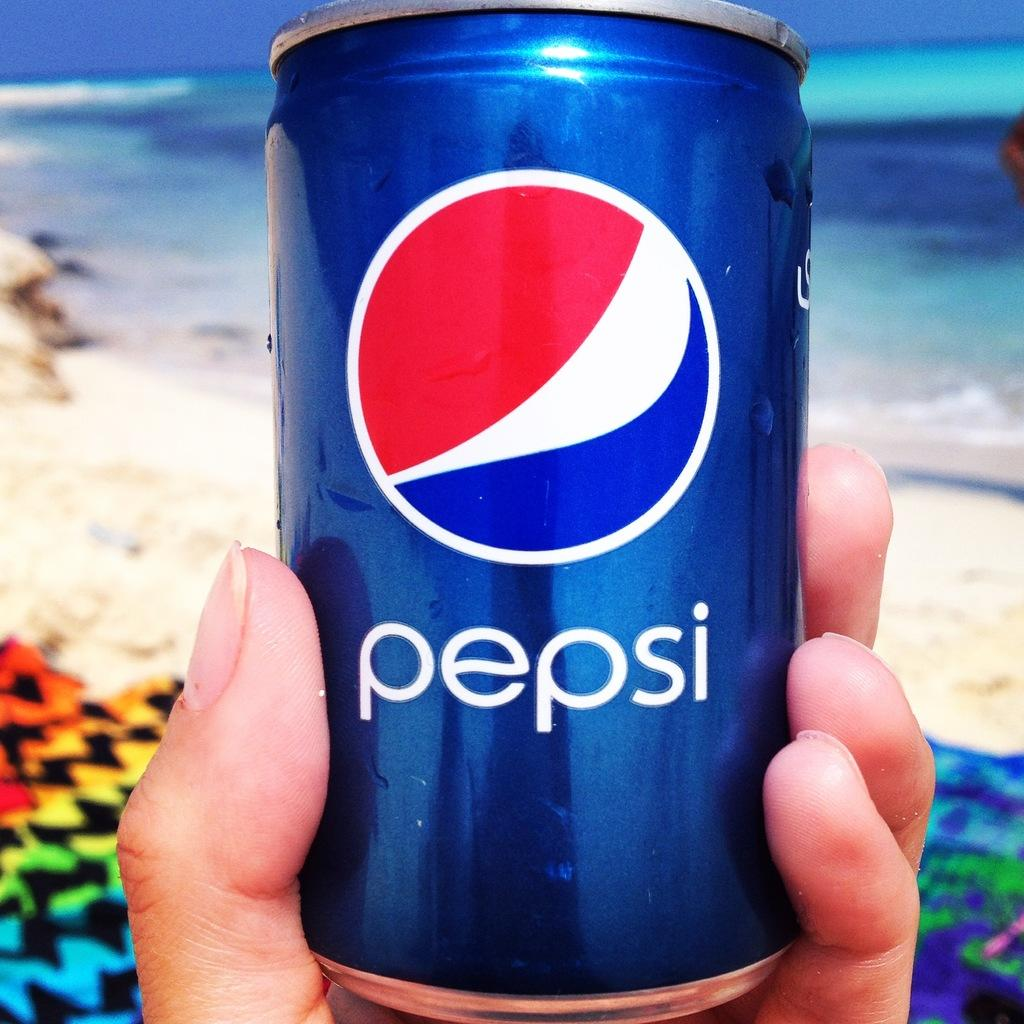Provide a one-sentence caption for the provided image. A hand holding a blue can that says pepsi in white letters. 